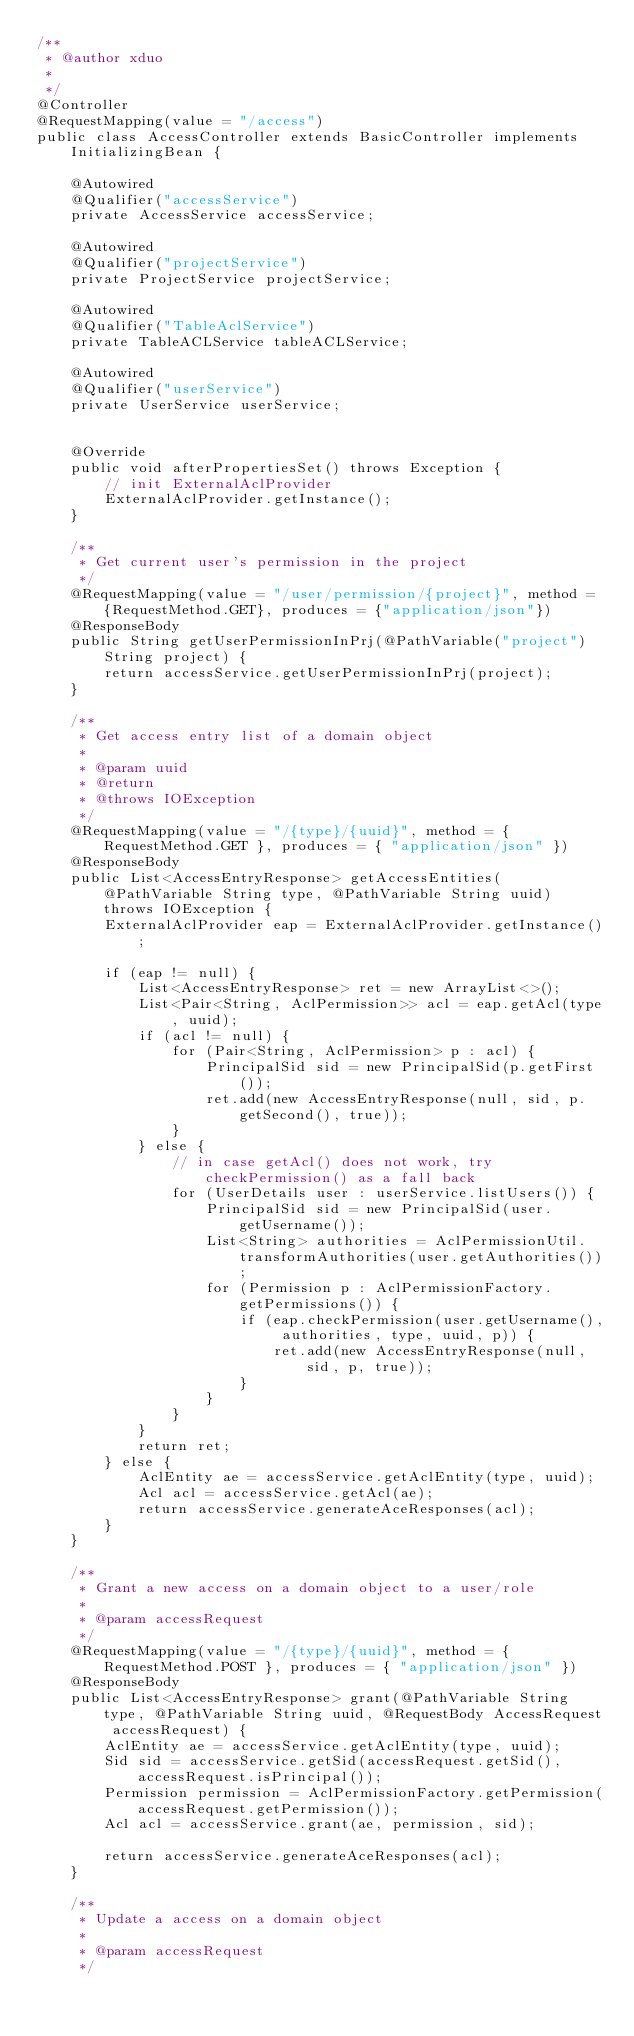<code> <loc_0><loc_0><loc_500><loc_500><_Java_>/**
 * @author xduo
 * 
 */
@Controller
@RequestMapping(value = "/access")
public class AccessController extends BasicController implements InitializingBean {

    @Autowired
    @Qualifier("accessService")
    private AccessService accessService;

    @Autowired
    @Qualifier("projectService")
    private ProjectService projectService;

    @Autowired
    @Qualifier("TableAclService")
    private TableACLService tableACLService;

    @Autowired
    @Qualifier("userService")
    private UserService userService;

    
    @Override
    public void afterPropertiesSet() throws Exception {
        // init ExternalAclProvider
        ExternalAclProvider.getInstance();
    }
    
    /**
     * Get current user's permission in the project
     */
    @RequestMapping(value = "/user/permission/{project}", method = {RequestMethod.GET}, produces = {"application/json"})
    @ResponseBody
    public String getUserPermissionInPrj(@PathVariable("project") String project) {
        return accessService.getUserPermissionInPrj(project);
    }

    /**
     * Get access entry list of a domain object
     * 
     * @param uuid
     * @return
     * @throws IOException
     */
    @RequestMapping(value = "/{type}/{uuid}", method = { RequestMethod.GET }, produces = { "application/json" })
    @ResponseBody
    public List<AccessEntryResponse> getAccessEntities(@PathVariable String type, @PathVariable String uuid) throws IOException {
        ExternalAclProvider eap = ExternalAclProvider.getInstance();

        if (eap != null) {
            List<AccessEntryResponse> ret = new ArrayList<>();
            List<Pair<String, AclPermission>> acl = eap.getAcl(type, uuid);
            if (acl != null) {
                for (Pair<String, AclPermission> p : acl) {
                    PrincipalSid sid = new PrincipalSid(p.getFirst());
                    ret.add(new AccessEntryResponse(null, sid, p.getSecond(), true));
                }
            } else {
                // in case getAcl() does not work, try checkPermission() as a fall back
                for (UserDetails user : userService.listUsers()) {
                    PrincipalSid sid = new PrincipalSid(user.getUsername());
                    List<String> authorities = AclPermissionUtil.transformAuthorities(user.getAuthorities());
                    for (Permission p : AclPermissionFactory.getPermissions()) {
                        if (eap.checkPermission(user.getUsername(), authorities, type, uuid, p)) {
                            ret.add(new AccessEntryResponse(null, sid, p, true));
                        }
                    }
                }
            }
            return ret;
        } else {
            AclEntity ae = accessService.getAclEntity(type, uuid);
            Acl acl = accessService.getAcl(ae);
            return accessService.generateAceResponses(acl);
        }
    }

    /**
     * Grant a new access on a domain object to a user/role
     * 
     * @param accessRequest
     */
    @RequestMapping(value = "/{type}/{uuid}", method = { RequestMethod.POST }, produces = { "application/json" })
    @ResponseBody
    public List<AccessEntryResponse> grant(@PathVariable String type, @PathVariable String uuid, @RequestBody AccessRequest accessRequest) {
        AclEntity ae = accessService.getAclEntity(type, uuid);
        Sid sid = accessService.getSid(accessRequest.getSid(), accessRequest.isPrincipal());
        Permission permission = AclPermissionFactory.getPermission(accessRequest.getPermission());
        Acl acl = accessService.grant(ae, permission, sid);

        return accessService.generateAceResponses(acl);
    }

    /**
     * Update a access on a domain object
     * 
     * @param accessRequest
     */</code> 